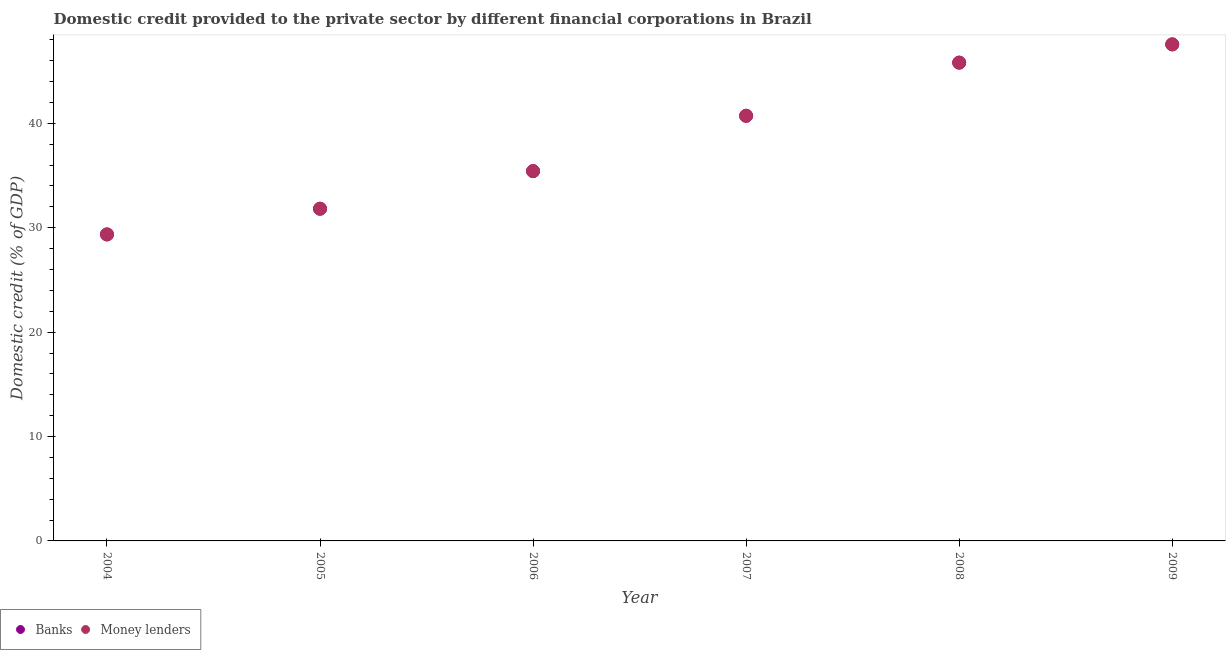How many different coloured dotlines are there?
Your response must be concise. 2. What is the domestic credit provided by banks in 2005?
Keep it short and to the point. 31.82. Across all years, what is the maximum domestic credit provided by money lenders?
Provide a succinct answer. 47.56. Across all years, what is the minimum domestic credit provided by money lenders?
Provide a succinct answer. 29.36. What is the total domestic credit provided by banks in the graph?
Give a very brief answer. 230.71. What is the difference between the domestic credit provided by banks in 2006 and that in 2008?
Provide a short and direct response. -10.4. What is the difference between the domestic credit provided by banks in 2006 and the domestic credit provided by money lenders in 2004?
Offer a very short reply. 6.06. What is the average domestic credit provided by money lenders per year?
Offer a very short reply. 38.45. In the year 2008, what is the difference between the domestic credit provided by banks and domestic credit provided by money lenders?
Give a very brief answer. 0. In how many years, is the domestic credit provided by banks greater than 28 %?
Keep it short and to the point. 6. What is the ratio of the domestic credit provided by money lenders in 2008 to that in 2009?
Ensure brevity in your answer.  0.96. What is the difference between the highest and the second highest domestic credit provided by banks?
Provide a short and direct response. 1.75. What is the difference between the highest and the lowest domestic credit provided by banks?
Your response must be concise. 18.21. Is the sum of the domestic credit provided by banks in 2005 and 2006 greater than the maximum domestic credit provided by money lenders across all years?
Offer a very short reply. Yes. Does the domestic credit provided by banks monotonically increase over the years?
Ensure brevity in your answer.  Yes. Is the domestic credit provided by money lenders strictly greater than the domestic credit provided by banks over the years?
Ensure brevity in your answer.  No. Is the domestic credit provided by money lenders strictly less than the domestic credit provided by banks over the years?
Keep it short and to the point. No. What is the difference between two consecutive major ticks on the Y-axis?
Offer a terse response. 10. Does the graph contain any zero values?
Give a very brief answer. No. How are the legend labels stacked?
Make the answer very short. Horizontal. What is the title of the graph?
Make the answer very short. Domestic credit provided to the private sector by different financial corporations in Brazil. What is the label or title of the Y-axis?
Your answer should be very brief. Domestic credit (% of GDP). What is the Domestic credit (% of GDP) in Banks in 2004?
Provide a succinct answer. 29.36. What is the Domestic credit (% of GDP) of Money lenders in 2004?
Your answer should be very brief. 29.36. What is the Domestic credit (% of GDP) in Banks in 2005?
Provide a succinct answer. 31.82. What is the Domestic credit (% of GDP) of Money lenders in 2005?
Your answer should be compact. 31.82. What is the Domestic credit (% of GDP) in Banks in 2006?
Offer a very short reply. 35.42. What is the Domestic credit (% of GDP) of Money lenders in 2006?
Ensure brevity in your answer.  35.42. What is the Domestic credit (% of GDP) of Banks in 2007?
Offer a terse response. 40.72. What is the Domestic credit (% of GDP) in Money lenders in 2007?
Offer a terse response. 40.72. What is the Domestic credit (% of GDP) in Banks in 2008?
Ensure brevity in your answer.  45.82. What is the Domestic credit (% of GDP) of Money lenders in 2008?
Give a very brief answer. 45.82. What is the Domestic credit (% of GDP) in Banks in 2009?
Keep it short and to the point. 47.56. What is the Domestic credit (% of GDP) in Money lenders in 2009?
Your response must be concise. 47.56. Across all years, what is the maximum Domestic credit (% of GDP) in Banks?
Your response must be concise. 47.56. Across all years, what is the maximum Domestic credit (% of GDP) of Money lenders?
Provide a short and direct response. 47.56. Across all years, what is the minimum Domestic credit (% of GDP) of Banks?
Your answer should be very brief. 29.36. Across all years, what is the minimum Domestic credit (% of GDP) of Money lenders?
Provide a succinct answer. 29.36. What is the total Domestic credit (% of GDP) in Banks in the graph?
Your answer should be very brief. 230.71. What is the total Domestic credit (% of GDP) in Money lenders in the graph?
Offer a very short reply. 230.71. What is the difference between the Domestic credit (% of GDP) of Banks in 2004 and that in 2005?
Keep it short and to the point. -2.46. What is the difference between the Domestic credit (% of GDP) of Money lenders in 2004 and that in 2005?
Ensure brevity in your answer.  -2.46. What is the difference between the Domestic credit (% of GDP) in Banks in 2004 and that in 2006?
Your answer should be very brief. -6.06. What is the difference between the Domestic credit (% of GDP) of Money lenders in 2004 and that in 2006?
Keep it short and to the point. -6.06. What is the difference between the Domestic credit (% of GDP) of Banks in 2004 and that in 2007?
Your response must be concise. -11.37. What is the difference between the Domestic credit (% of GDP) in Money lenders in 2004 and that in 2007?
Your answer should be very brief. -11.37. What is the difference between the Domestic credit (% of GDP) of Banks in 2004 and that in 2008?
Your answer should be very brief. -16.46. What is the difference between the Domestic credit (% of GDP) in Money lenders in 2004 and that in 2008?
Your answer should be compact. -16.46. What is the difference between the Domestic credit (% of GDP) of Banks in 2004 and that in 2009?
Keep it short and to the point. -18.21. What is the difference between the Domestic credit (% of GDP) in Money lenders in 2004 and that in 2009?
Your answer should be compact. -18.21. What is the difference between the Domestic credit (% of GDP) of Banks in 2005 and that in 2006?
Your answer should be very brief. -3.6. What is the difference between the Domestic credit (% of GDP) of Money lenders in 2005 and that in 2006?
Ensure brevity in your answer.  -3.6. What is the difference between the Domestic credit (% of GDP) of Banks in 2005 and that in 2007?
Your response must be concise. -8.9. What is the difference between the Domestic credit (% of GDP) in Money lenders in 2005 and that in 2007?
Keep it short and to the point. -8.9. What is the difference between the Domestic credit (% of GDP) in Banks in 2005 and that in 2008?
Make the answer very short. -13.99. What is the difference between the Domestic credit (% of GDP) in Money lenders in 2005 and that in 2008?
Provide a short and direct response. -13.99. What is the difference between the Domestic credit (% of GDP) in Banks in 2005 and that in 2009?
Give a very brief answer. -15.74. What is the difference between the Domestic credit (% of GDP) of Money lenders in 2005 and that in 2009?
Make the answer very short. -15.74. What is the difference between the Domestic credit (% of GDP) in Banks in 2006 and that in 2007?
Your answer should be compact. -5.3. What is the difference between the Domestic credit (% of GDP) in Money lenders in 2006 and that in 2007?
Offer a terse response. -5.3. What is the difference between the Domestic credit (% of GDP) in Banks in 2006 and that in 2008?
Provide a succinct answer. -10.4. What is the difference between the Domestic credit (% of GDP) of Money lenders in 2006 and that in 2008?
Keep it short and to the point. -10.4. What is the difference between the Domestic credit (% of GDP) of Banks in 2006 and that in 2009?
Provide a short and direct response. -12.14. What is the difference between the Domestic credit (% of GDP) in Money lenders in 2006 and that in 2009?
Offer a terse response. -12.14. What is the difference between the Domestic credit (% of GDP) of Banks in 2007 and that in 2008?
Provide a succinct answer. -5.09. What is the difference between the Domestic credit (% of GDP) in Money lenders in 2007 and that in 2008?
Your response must be concise. -5.09. What is the difference between the Domestic credit (% of GDP) of Banks in 2007 and that in 2009?
Your response must be concise. -6.84. What is the difference between the Domestic credit (% of GDP) of Money lenders in 2007 and that in 2009?
Provide a succinct answer. -6.84. What is the difference between the Domestic credit (% of GDP) of Banks in 2008 and that in 2009?
Make the answer very short. -1.75. What is the difference between the Domestic credit (% of GDP) in Money lenders in 2008 and that in 2009?
Ensure brevity in your answer.  -1.75. What is the difference between the Domestic credit (% of GDP) in Banks in 2004 and the Domestic credit (% of GDP) in Money lenders in 2005?
Provide a succinct answer. -2.46. What is the difference between the Domestic credit (% of GDP) of Banks in 2004 and the Domestic credit (% of GDP) of Money lenders in 2006?
Your response must be concise. -6.06. What is the difference between the Domestic credit (% of GDP) of Banks in 2004 and the Domestic credit (% of GDP) of Money lenders in 2007?
Keep it short and to the point. -11.37. What is the difference between the Domestic credit (% of GDP) in Banks in 2004 and the Domestic credit (% of GDP) in Money lenders in 2008?
Give a very brief answer. -16.46. What is the difference between the Domestic credit (% of GDP) of Banks in 2004 and the Domestic credit (% of GDP) of Money lenders in 2009?
Offer a terse response. -18.21. What is the difference between the Domestic credit (% of GDP) in Banks in 2005 and the Domestic credit (% of GDP) in Money lenders in 2006?
Your answer should be very brief. -3.6. What is the difference between the Domestic credit (% of GDP) in Banks in 2005 and the Domestic credit (% of GDP) in Money lenders in 2007?
Keep it short and to the point. -8.9. What is the difference between the Domestic credit (% of GDP) in Banks in 2005 and the Domestic credit (% of GDP) in Money lenders in 2008?
Provide a succinct answer. -13.99. What is the difference between the Domestic credit (% of GDP) of Banks in 2005 and the Domestic credit (% of GDP) of Money lenders in 2009?
Your response must be concise. -15.74. What is the difference between the Domestic credit (% of GDP) of Banks in 2006 and the Domestic credit (% of GDP) of Money lenders in 2007?
Your response must be concise. -5.3. What is the difference between the Domestic credit (% of GDP) in Banks in 2006 and the Domestic credit (% of GDP) in Money lenders in 2008?
Your response must be concise. -10.4. What is the difference between the Domestic credit (% of GDP) of Banks in 2006 and the Domestic credit (% of GDP) of Money lenders in 2009?
Provide a succinct answer. -12.14. What is the difference between the Domestic credit (% of GDP) of Banks in 2007 and the Domestic credit (% of GDP) of Money lenders in 2008?
Provide a succinct answer. -5.09. What is the difference between the Domestic credit (% of GDP) in Banks in 2007 and the Domestic credit (% of GDP) in Money lenders in 2009?
Keep it short and to the point. -6.84. What is the difference between the Domestic credit (% of GDP) in Banks in 2008 and the Domestic credit (% of GDP) in Money lenders in 2009?
Provide a succinct answer. -1.75. What is the average Domestic credit (% of GDP) of Banks per year?
Provide a succinct answer. 38.45. What is the average Domestic credit (% of GDP) in Money lenders per year?
Offer a terse response. 38.45. In the year 2004, what is the difference between the Domestic credit (% of GDP) in Banks and Domestic credit (% of GDP) in Money lenders?
Provide a short and direct response. 0. In the year 2007, what is the difference between the Domestic credit (% of GDP) of Banks and Domestic credit (% of GDP) of Money lenders?
Your answer should be very brief. 0. What is the ratio of the Domestic credit (% of GDP) of Banks in 2004 to that in 2005?
Offer a terse response. 0.92. What is the ratio of the Domestic credit (% of GDP) of Money lenders in 2004 to that in 2005?
Offer a terse response. 0.92. What is the ratio of the Domestic credit (% of GDP) of Banks in 2004 to that in 2006?
Keep it short and to the point. 0.83. What is the ratio of the Domestic credit (% of GDP) of Money lenders in 2004 to that in 2006?
Provide a succinct answer. 0.83. What is the ratio of the Domestic credit (% of GDP) of Banks in 2004 to that in 2007?
Provide a succinct answer. 0.72. What is the ratio of the Domestic credit (% of GDP) in Money lenders in 2004 to that in 2007?
Ensure brevity in your answer.  0.72. What is the ratio of the Domestic credit (% of GDP) in Banks in 2004 to that in 2008?
Make the answer very short. 0.64. What is the ratio of the Domestic credit (% of GDP) in Money lenders in 2004 to that in 2008?
Keep it short and to the point. 0.64. What is the ratio of the Domestic credit (% of GDP) of Banks in 2004 to that in 2009?
Offer a terse response. 0.62. What is the ratio of the Domestic credit (% of GDP) of Money lenders in 2004 to that in 2009?
Provide a short and direct response. 0.62. What is the ratio of the Domestic credit (% of GDP) of Banks in 2005 to that in 2006?
Your answer should be very brief. 0.9. What is the ratio of the Domestic credit (% of GDP) of Money lenders in 2005 to that in 2006?
Give a very brief answer. 0.9. What is the ratio of the Domestic credit (% of GDP) in Banks in 2005 to that in 2007?
Ensure brevity in your answer.  0.78. What is the ratio of the Domestic credit (% of GDP) of Money lenders in 2005 to that in 2007?
Make the answer very short. 0.78. What is the ratio of the Domestic credit (% of GDP) in Banks in 2005 to that in 2008?
Offer a terse response. 0.69. What is the ratio of the Domestic credit (% of GDP) of Money lenders in 2005 to that in 2008?
Your response must be concise. 0.69. What is the ratio of the Domestic credit (% of GDP) of Banks in 2005 to that in 2009?
Ensure brevity in your answer.  0.67. What is the ratio of the Domestic credit (% of GDP) in Money lenders in 2005 to that in 2009?
Offer a very short reply. 0.67. What is the ratio of the Domestic credit (% of GDP) of Banks in 2006 to that in 2007?
Your answer should be compact. 0.87. What is the ratio of the Domestic credit (% of GDP) in Money lenders in 2006 to that in 2007?
Offer a terse response. 0.87. What is the ratio of the Domestic credit (% of GDP) of Banks in 2006 to that in 2008?
Your response must be concise. 0.77. What is the ratio of the Domestic credit (% of GDP) in Money lenders in 2006 to that in 2008?
Offer a terse response. 0.77. What is the ratio of the Domestic credit (% of GDP) in Banks in 2006 to that in 2009?
Your answer should be compact. 0.74. What is the ratio of the Domestic credit (% of GDP) of Money lenders in 2006 to that in 2009?
Offer a terse response. 0.74. What is the ratio of the Domestic credit (% of GDP) in Money lenders in 2007 to that in 2008?
Provide a short and direct response. 0.89. What is the ratio of the Domestic credit (% of GDP) of Banks in 2007 to that in 2009?
Offer a terse response. 0.86. What is the ratio of the Domestic credit (% of GDP) in Money lenders in 2007 to that in 2009?
Your answer should be very brief. 0.86. What is the ratio of the Domestic credit (% of GDP) of Banks in 2008 to that in 2009?
Provide a short and direct response. 0.96. What is the ratio of the Domestic credit (% of GDP) of Money lenders in 2008 to that in 2009?
Make the answer very short. 0.96. What is the difference between the highest and the second highest Domestic credit (% of GDP) of Banks?
Your answer should be compact. 1.75. What is the difference between the highest and the second highest Domestic credit (% of GDP) of Money lenders?
Provide a succinct answer. 1.75. What is the difference between the highest and the lowest Domestic credit (% of GDP) in Banks?
Provide a succinct answer. 18.21. What is the difference between the highest and the lowest Domestic credit (% of GDP) of Money lenders?
Offer a terse response. 18.21. 